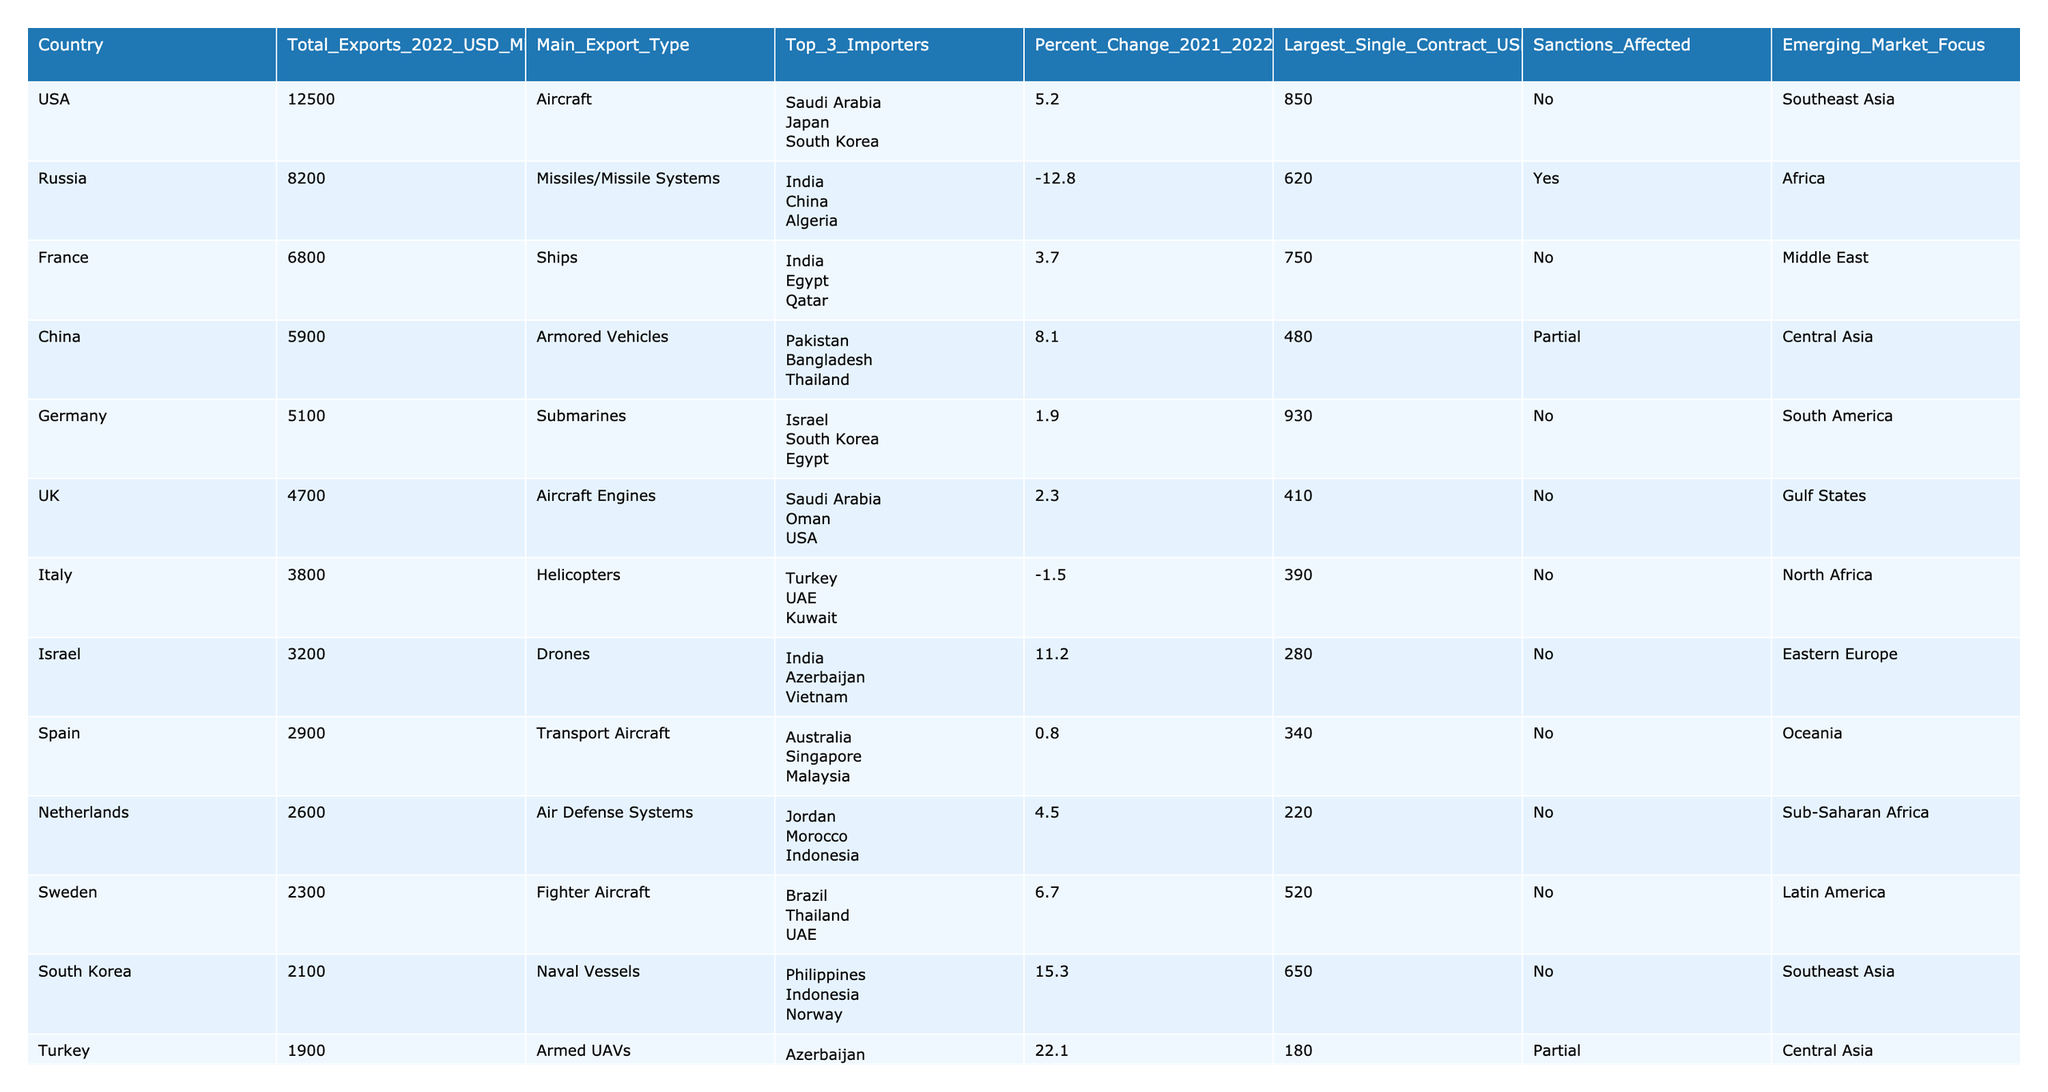What country had the largest total arms exports in 2022? By examining the 'Total_Exports_2022_USD_Millions' column, the value for the USA is the highest at 12,500 million USD.
Answer: USA Which country experienced the largest percent change in arms exports from 2021 to 2022? The 'Percent_Change_2021_2022' column shows that Turkey had the largest positive change at +22.1%.
Answer: Turkey What was the main export type for Germany? The 'Main_Export_Type' column lists submarines as the primary export type for Germany.
Answer: Submarines Which three countries are the top importers of French arms? From the 'Top_3_Importers' column, India, Egypt, and Qatar are the top three importers for France.
Answer: India, Egypt, Qatar What is the total arms export value for the top three exporting nations combined? Adding the total exports of USA (12,500), Russia (8,200), and France (6,800) gives: 12,500 + 8,200 + 6,800 = 27,500 million USD.
Answer: 27,500 million USD Did any of the top 20 exporting countries face sanctions? By reviewing the 'Sanctions_Affected' column, we identify that Russia, Ukraine, and Belarus are affected by sanctions.
Answer: Yes Which country focused its arms exports on emerging markets with a non-zero sanctions status? By looking at the 'Emerging_Market_Focus' and 'Sanctions_Affected' columns, we see that Turkey targets Central Asia while being partially sanctioned.
Answer: Turkey Which country had the largest single arms contract and what was its value? The 'Largest_Single_Contract_USD_Millions' column indicates that the USA had the largest contract at 850 million USD.
Answer: 850 million USD How do the arms exports of the USA compare to those of Ukraine? The total exports for the USA are 12,500 million USD while for Ukraine they are 1,500 million USD. The difference is 12,500 - 1,500 = 11,000 million USD, meaning USA exports 11,000 million USD more than Ukraine.
Answer: 11,000 million USD more Among the countries exporting naval systems, which country had the highest total exports? From the data, Australia exports naval systems with a total of 900 million USD, which is also the only entry in this category, hence the highest.
Answer: Australia 